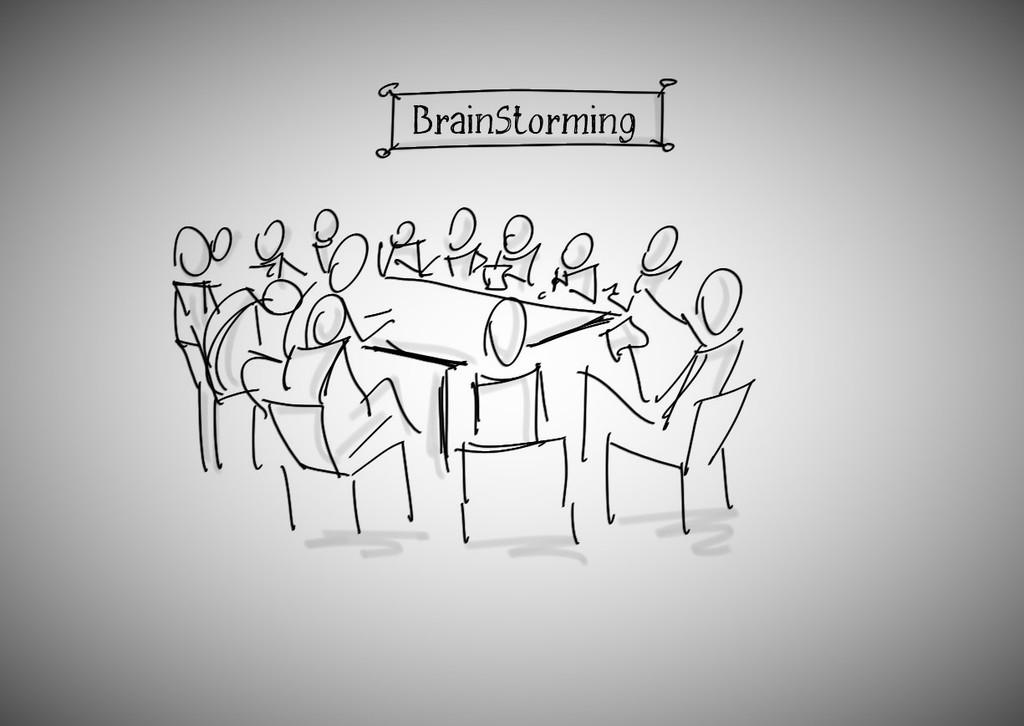What type of image is being described? The image is a drawing. What is shown in the drawing? There are persons and chairs depicted in the drawing. What type of food is being prepared on the sheet in the drawing? There is no sheet or food preparation depicted in the drawing; it only shows persons and chairs. 